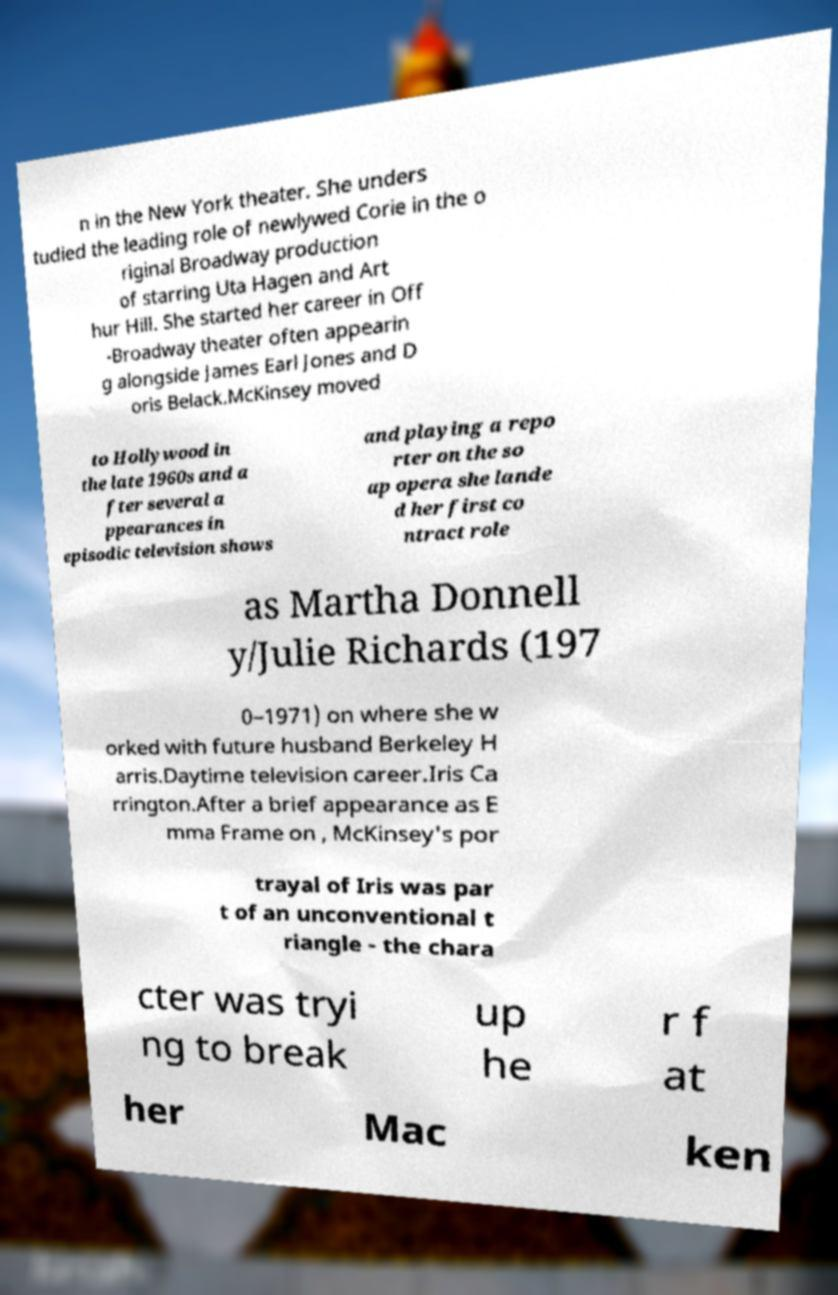Please identify and transcribe the text found in this image. n in the New York theater. She unders tudied the leading role of newlywed Corie in the o riginal Broadway production of starring Uta Hagen and Art hur Hill. She started her career in Off -Broadway theater often appearin g alongside James Earl Jones and D oris Belack.McKinsey moved to Hollywood in the late 1960s and a fter several a ppearances in episodic television shows and playing a repo rter on the so ap opera she lande d her first co ntract role as Martha Donnell y/Julie Richards (197 0–1971) on where she w orked with future husband Berkeley H arris.Daytime television career.Iris Ca rrington.After a brief appearance as E mma Frame on , McKinsey's por trayal of Iris was par t of an unconventional t riangle - the chara cter was tryi ng to break up he r f at her Mac ken 